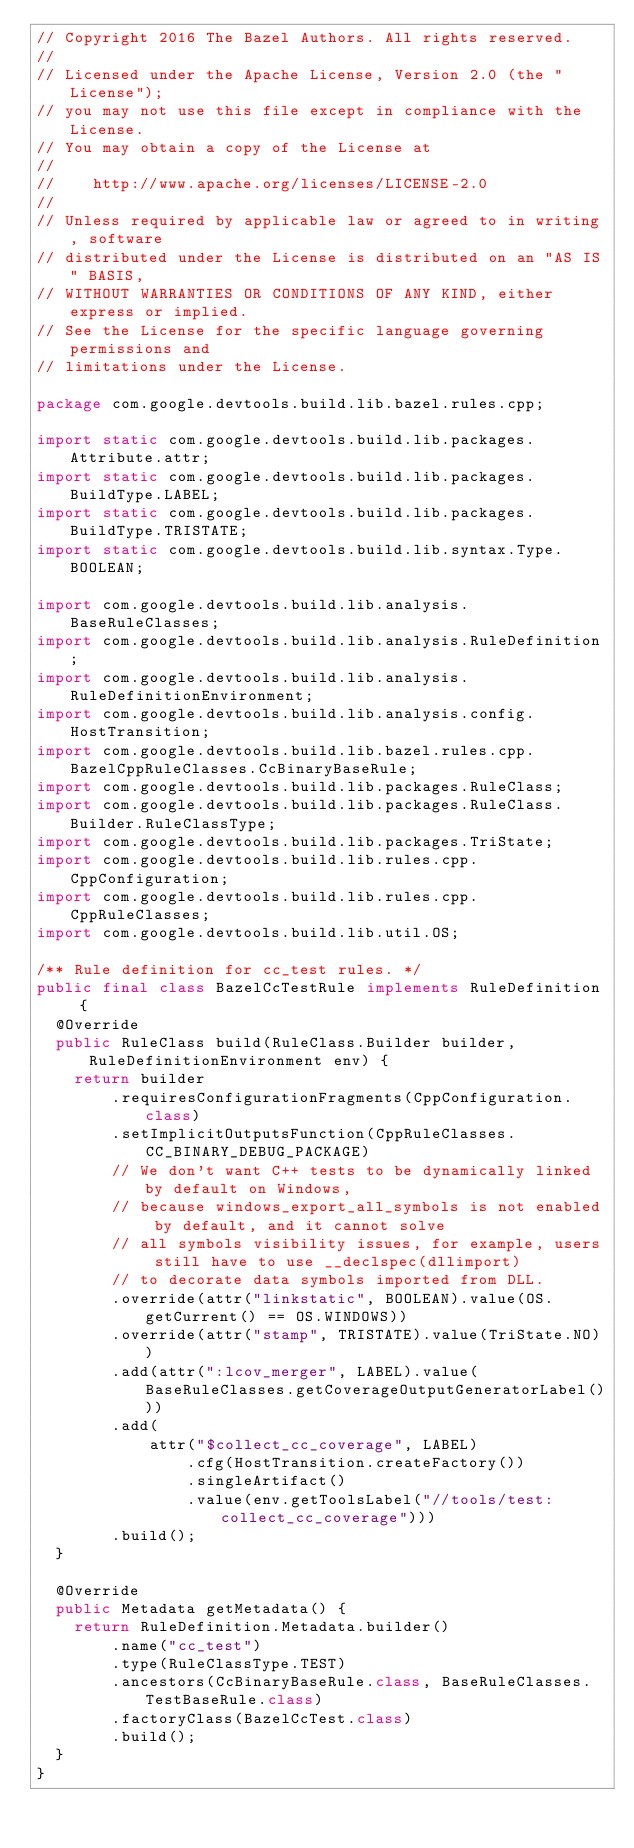<code> <loc_0><loc_0><loc_500><loc_500><_Java_>// Copyright 2016 The Bazel Authors. All rights reserved.
//
// Licensed under the Apache License, Version 2.0 (the "License");
// you may not use this file except in compliance with the License.
// You may obtain a copy of the License at
//
//    http://www.apache.org/licenses/LICENSE-2.0
//
// Unless required by applicable law or agreed to in writing, software
// distributed under the License is distributed on an "AS IS" BASIS,
// WITHOUT WARRANTIES OR CONDITIONS OF ANY KIND, either express or implied.
// See the License for the specific language governing permissions and
// limitations under the License.

package com.google.devtools.build.lib.bazel.rules.cpp;

import static com.google.devtools.build.lib.packages.Attribute.attr;
import static com.google.devtools.build.lib.packages.BuildType.LABEL;
import static com.google.devtools.build.lib.packages.BuildType.TRISTATE;
import static com.google.devtools.build.lib.syntax.Type.BOOLEAN;

import com.google.devtools.build.lib.analysis.BaseRuleClasses;
import com.google.devtools.build.lib.analysis.RuleDefinition;
import com.google.devtools.build.lib.analysis.RuleDefinitionEnvironment;
import com.google.devtools.build.lib.analysis.config.HostTransition;
import com.google.devtools.build.lib.bazel.rules.cpp.BazelCppRuleClasses.CcBinaryBaseRule;
import com.google.devtools.build.lib.packages.RuleClass;
import com.google.devtools.build.lib.packages.RuleClass.Builder.RuleClassType;
import com.google.devtools.build.lib.packages.TriState;
import com.google.devtools.build.lib.rules.cpp.CppConfiguration;
import com.google.devtools.build.lib.rules.cpp.CppRuleClasses;
import com.google.devtools.build.lib.util.OS;

/** Rule definition for cc_test rules. */
public final class BazelCcTestRule implements RuleDefinition {
  @Override
  public RuleClass build(RuleClass.Builder builder, RuleDefinitionEnvironment env) {
    return builder
        .requiresConfigurationFragments(CppConfiguration.class)
        .setImplicitOutputsFunction(CppRuleClasses.CC_BINARY_DEBUG_PACKAGE)
        // We don't want C++ tests to be dynamically linked by default on Windows,
        // because windows_export_all_symbols is not enabled by default, and it cannot solve
        // all symbols visibility issues, for example, users still have to use __declspec(dllimport)
        // to decorate data symbols imported from DLL.
        .override(attr("linkstatic", BOOLEAN).value(OS.getCurrent() == OS.WINDOWS))
        .override(attr("stamp", TRISTATE).value(TriState.NO))
        .add(attr(":lcov_merger", LABEL).value(BaseRuleClasses.getCoverageOutputGeneratorLabel()))
        .add(
            attr("$collect_cc_coverage", LABEL)
                .cfg(HostTransition.createFactory())
                .singleArtifact()
                .value(env.getToolsLabel("//tools/test:collect_cc_coverage")))
        .build();
  }

  @Override
  public Metadata getMetadata() {
    return RuleDefinition.Metadata.builder()
        .name("cc_test")
        .type(RuleClassType.TEST)
        .ancestors(CcBinaryBaseRule.class, BaseRuleClasses.TestBaseRule.class)
        .factoryClass(BazelCcTest.class)
        .build();
  }
}
</code> 